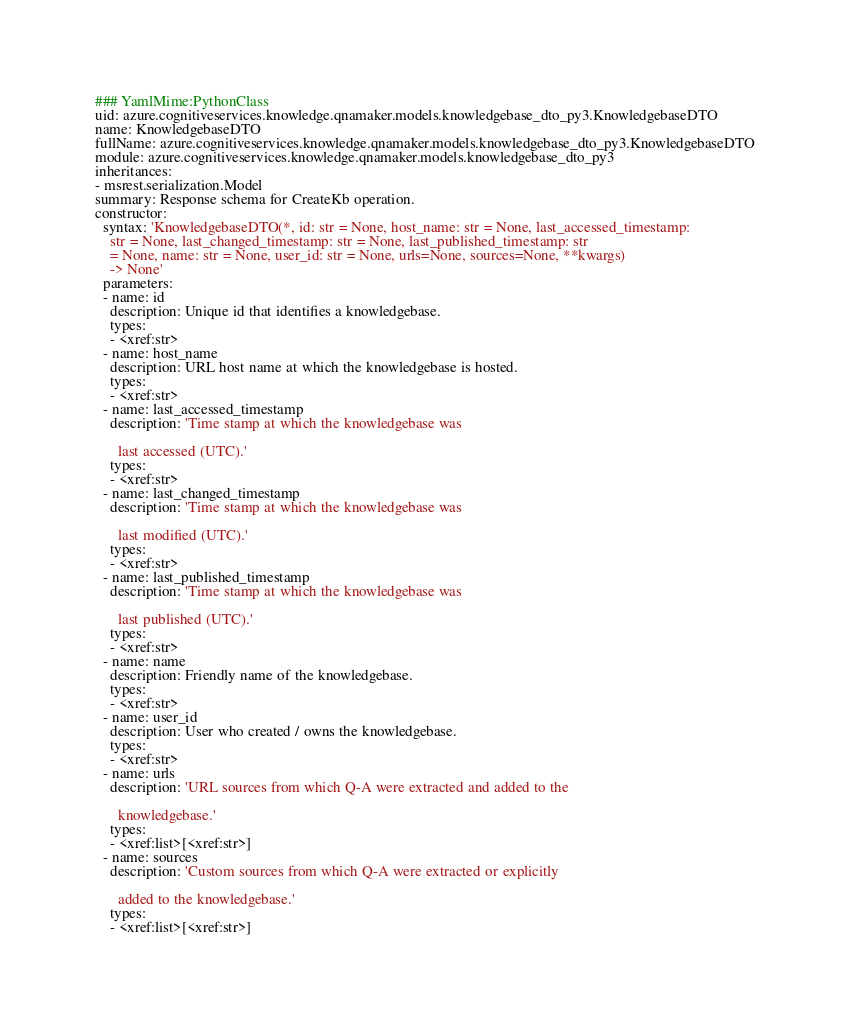Convert code to text. <code><loc_0><loc_0><loc_500><loc_500><_YAML_>### YamlMime:PythonClass
uid: azure.cognitiveservices.knowledge.qnamaker.models.knowledgebase_dto_py3.KnowledgebaseDTO
name: KnowledgebaseDTO
fullName: azure.cognitiveservices.knowledge.qnamaker.models.knowledgebase_dto_py3.KnowledgebaseDTO
module: azure.cognitiveservices.knowledge.qnamaker.models.knowledgebase_dto_py3
inheritances:
- msrest.serialization.Model
summary: Response schema for CreateKb operation.
constructor:
  syntax: 'KnowledgebaseDTO(*, id: str = None, host_name: str = None, last_accessed_timestamp:
    str = None, last_changed_timestamp: str = None, last_published_timestamp: str
    = None, name: str = None, user_id: str = None, urls=None, sources=None, **kwargs)
    -> None'
  parameters:
  - name: id
    description: Unique id that identifies a knowledgebase.
    types:
    - <xref:str>
  - name: host_name
    description: URL host name at which the knowledgebase is hosted.
    types:
    - <xref:str>
  - name: last_accessed_timestamp
    description: 'Time stamp at which the knowledgebase was

      last accessed (UTC).'
    types:
    - <xref:str>
  - name: last_changed_timestamp
    description: 'Time stamp at which the knowledgebase was

      last modified (UTC).'
    types:
    - <xref:str>
  - name: last_published_timestamp
    description: 'Time stamp at which the knowledgebase was

      last published (UTC).'
    types:
    - <xref:str>
  - name: name
    description: Friendly name of the knowledgebase.
    types:
    - <xref:str>
  - name: user_id
    description: User who created / owns the knowledgebase.
    types:
    - <xref:str>
  - name: urls
    description: 'URL sources from which Q-A were extracted and added to the

      knowledgebase.'
    types:
    - <xref:list>[<xref:str>]
  - name: sources
    description: 'Custom sources from which Q-A were extracted or explicitly

      added to the knowledgebase.'
    types:
    - <xref:list>[<xref:str>]
</code> 